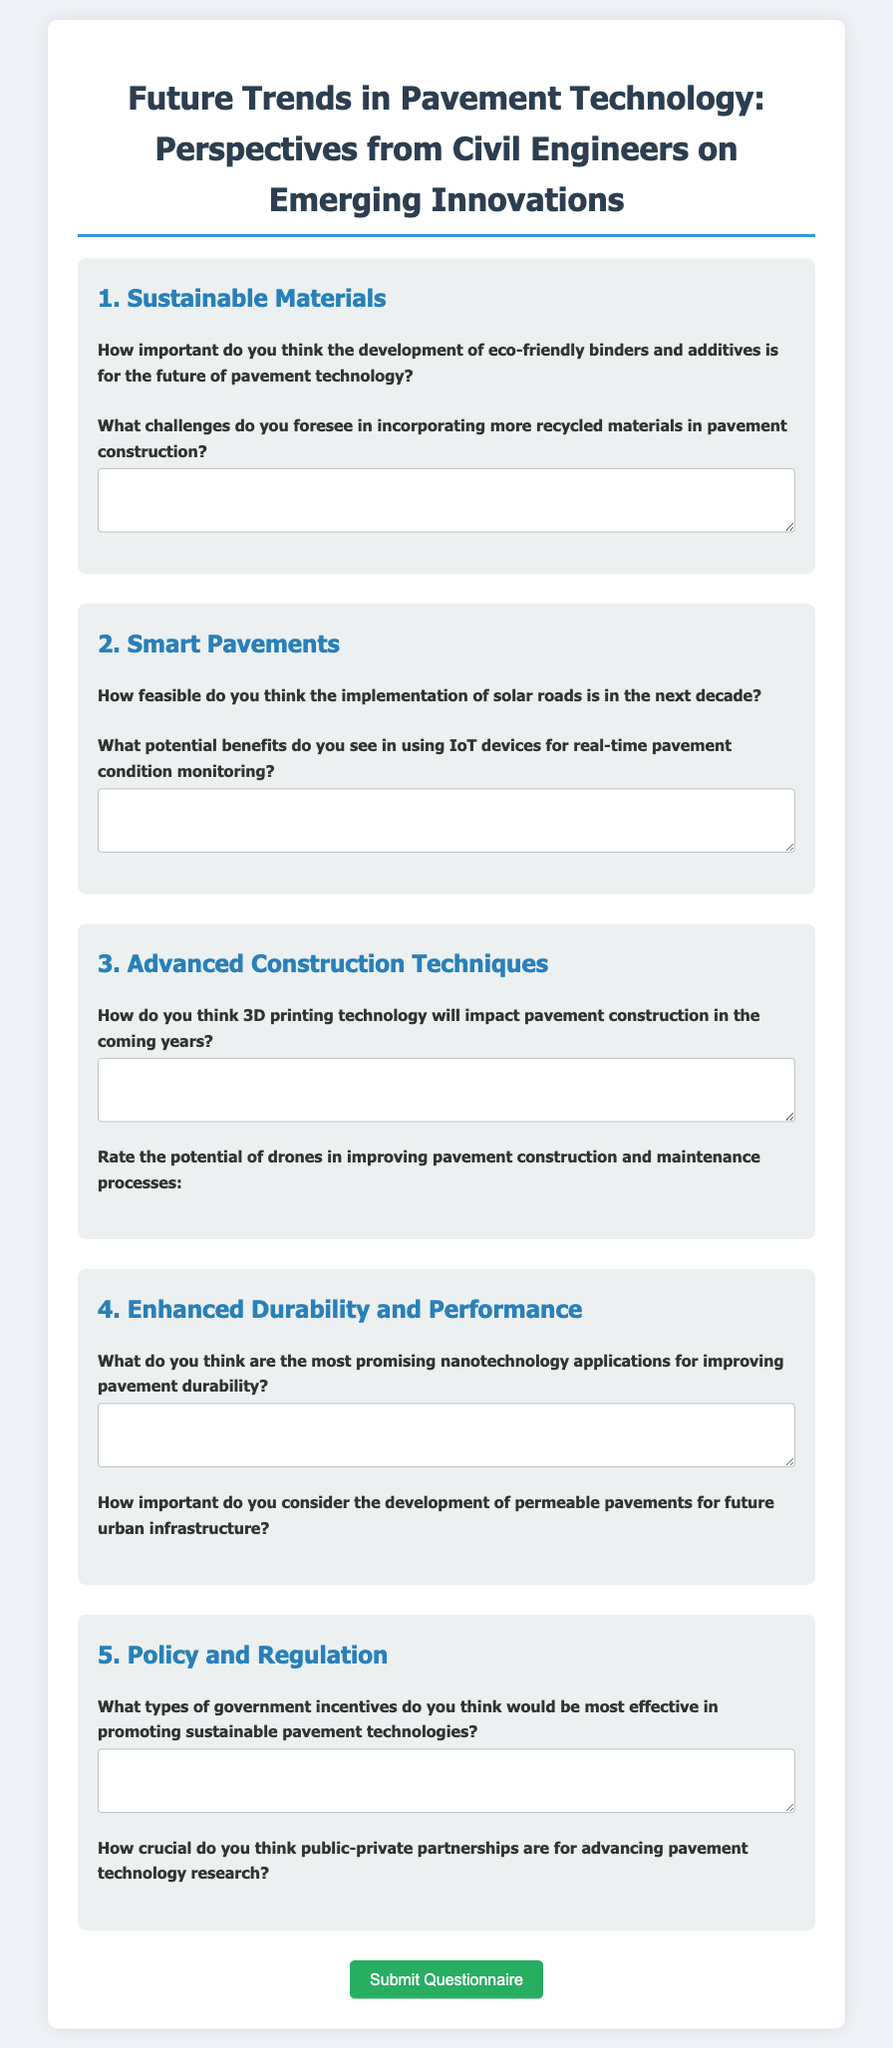What is the title of the questionnaire? The title is stated in the header of the document.
Answer: Future Trends in Pavement Technology: Perspectives from Civil Engineers on Emerging Innovations How many sections are there in the questionnaire? The sections are labeled in the document and can be counted.
Answer: 5 What rating scale is used for the questions? The document specifies a rating scale ranging from 1 to 5 stars.
Answer: 1 to 5 stars What is the focus of Section 1? The section headings indicate the focus areas of each section.
Answer: Sustainable Materials What type of question is found in Section 2 regarding solar roads? The question type is indicated by how it’s framed in the section.
Answer: Feasibility question What does the form provide for users to submit their responses? The document includes a button for submission.
Answer: Submit Questionnaire What is a potential benefit mentioned in Section 2? Users can answer based on the specific mention in the document.
Answer: IoT devices for real-time pavement condition monitoring How does the document describe the role of public-private partnerships? The importance is highlighted based on a question in the last section.
Answer: Crucial 